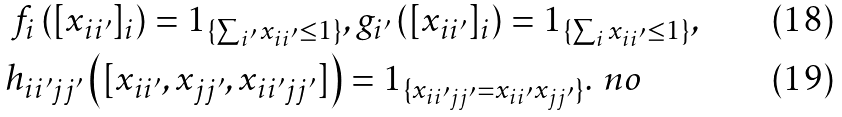Convert formula to latex. <formula><loc_0><loc_0><loc_500><loc_500>f _ { i } \left ( [ x _ { i i ^ { \prime } } ] _ { i } \right ) = 1 _ { \{ \sum _ { i ^ { \prime } } x _ { i i ^ { \prime } } \leq 1 \} } & , g _ { i ^ { \prime } } \left ( [ x _ { i i ^ { \prime } } ] _ { i } \right ) = 1 _ { \{ \sum _ { i } x _ { i i ^ { \prime } } \leq 1 \} } , \\ h _ { i i ^ { \prime } j j ^ { \prime } } \left ( [ x _ { i i ^ { \prime } } , x _ { j j ^ { \prime } } , x _ { i i ^ { \prime } j j ^ { \prime } } ] \right ) & = 1 _ { \{ x _ { i i ^ { \prime } j j ^ { \prime } } = x _ { i i ^ { \prime } } x _ { j j ^ { \prime } } \} } . \ n o</formula> 